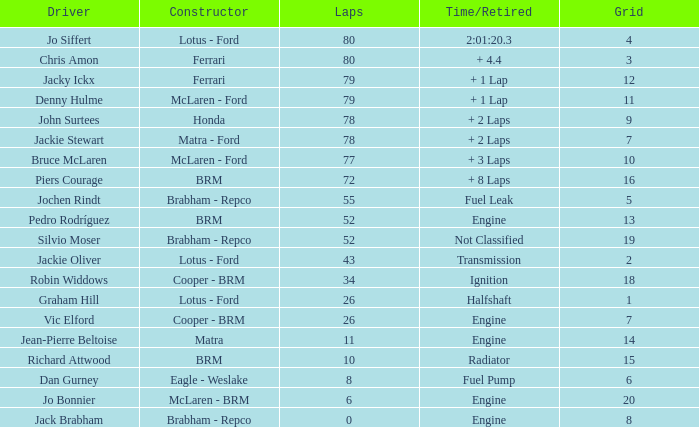When laps are less than 80 and Bruce mclaren is the driver, what is the grid? 10.0. 